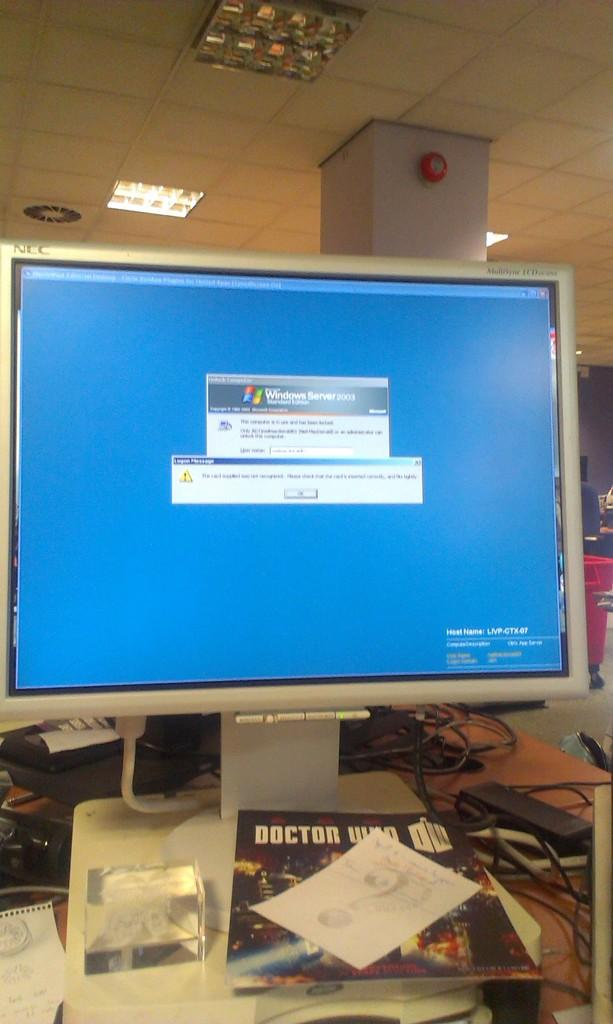Provide a one-sentence caption for the provided image. The operating system running is Microsoft Server 2003. 